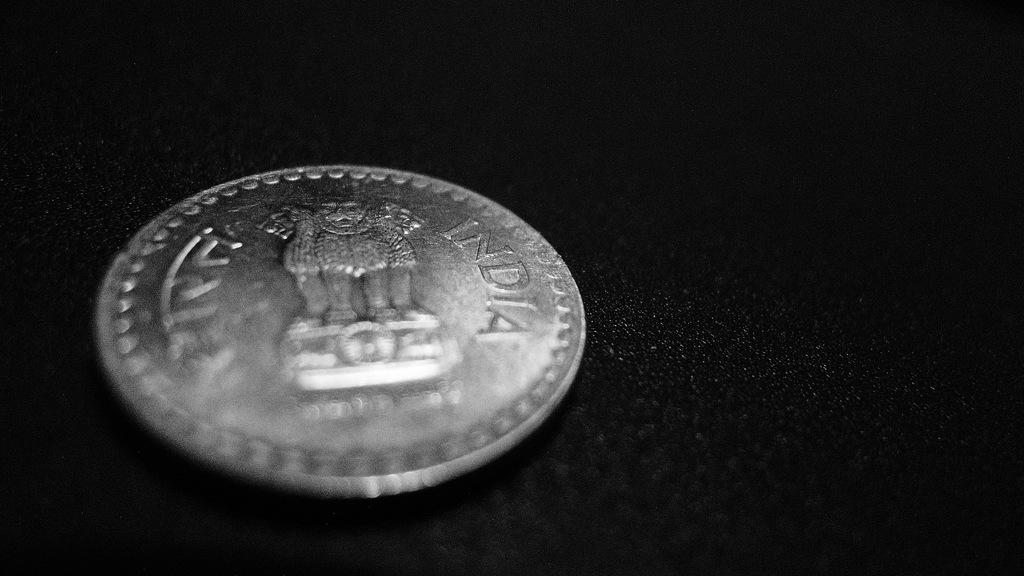<image>
Offer a succinct explanation of the picture presented. A silver coin from India featuring some type of creature on the back. 